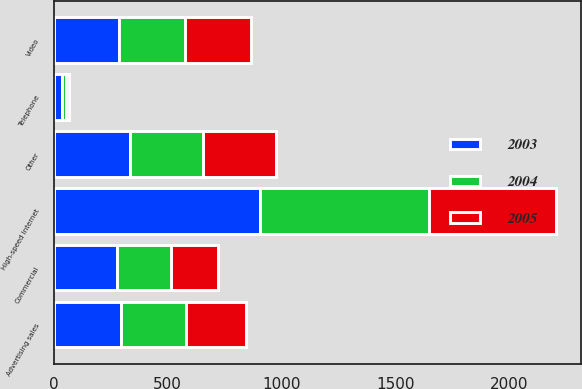Convert chart. <chart><loc_0><loc_0><loc_500><loc_500><stacked_bar_chart><ecel><fcel>Video<fcel>High-speed Internet<fcel>Telephone<fcel>Advertising sales<fcel>Commercial<fcel>Other<nl><fcel>2003<fcel>289<fcel>908<fcel>36<fcel>294<fcel>279<fcel>336<nl><fcel>2004<fcel>289<fcel>741<fcel>18<fcel>289<fcel>238<fcel>318<nl><fcel>2005<fcel>289<fcel>556<fcel>14<fcel>263<fcel>204<fcel>321<nl></chart> 